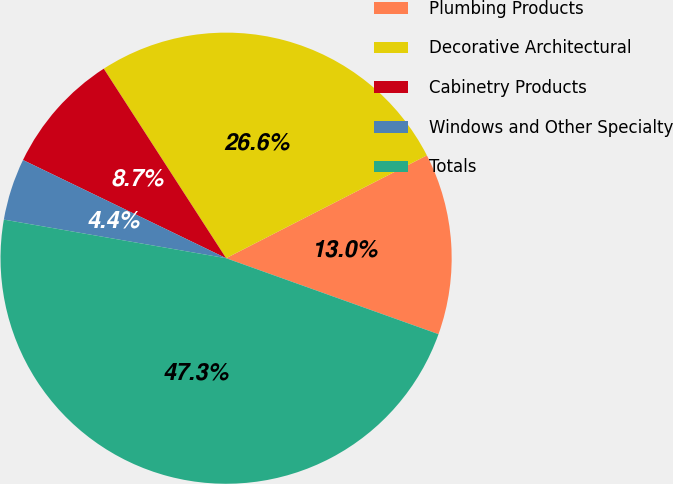<chart> <loc_0><loc_0><loc_500><loc_500><pie_chart><fcel>Plumbing Products<fcel>Decorative Architectural<fcel>Cabinetry Products<fcel>Windows and Other Specialty<fcel>Totals<nl><fcel>13.0%<fcel>26.59%<fcel>8.71%<fcel>4.43%<fcel>47.27%<nl></chart> 